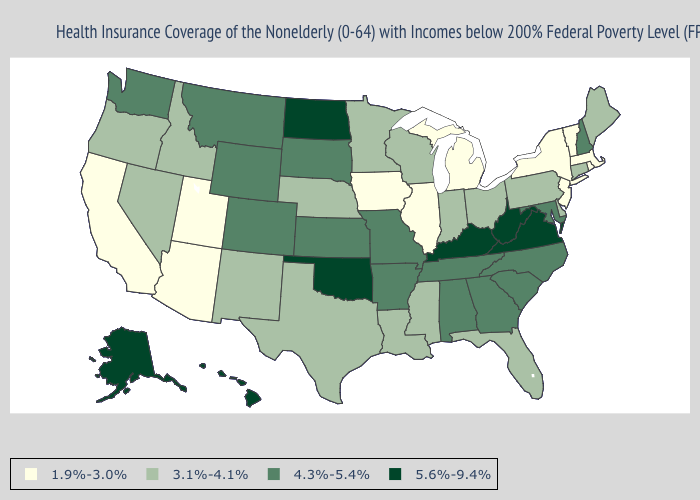What is the value of Kentucky?
Short answer required. 5.6%-9.4%. Does Iowa have the lowest value in the MidWest?
Answer briefly. Yes. Among the states that border North Carolina , does Virginia have the lowest value?
Keep it brief. No. What is the value of Kansas?
Quick response, please. 4.3%-5.4%. Name the states that have a value in the range 3.1%-4.1%?
Keep it brief. Connecticut, Delaware, Florida, Idaho, Indiana, Louisiana, Maine, Minnesota, Mississippi, Nebraska, Nevada, New Mexico, Ohio, Oregon, Pennsylvania, Texas, Wisconsin. Among the states that border New Jersey , does Pennsylvania have the lowest value?
Answer briefly. No. What is the value of West Virginia?
Concise answer only. 5.6%-9.4%. What is the highest value in the West ?
Concise answer only. 5.6%-9.4%. Which states hav the highest value in the MidWest?
Answer briefly. North Dakota. What is the value of Georgia?
Concise answer only. 4.3%-5.4%. Among the states that border Missouri , does Illinois have the lowest value?
Be succinct. Yes. Does Montana have the highest value in the USA?
Answer briefly. No. What is the value of Kentucky?
Short answer required. 5.6%-9.4%. What is the value of Oregon?
Quick response, please. 3.1%-4.1%. 